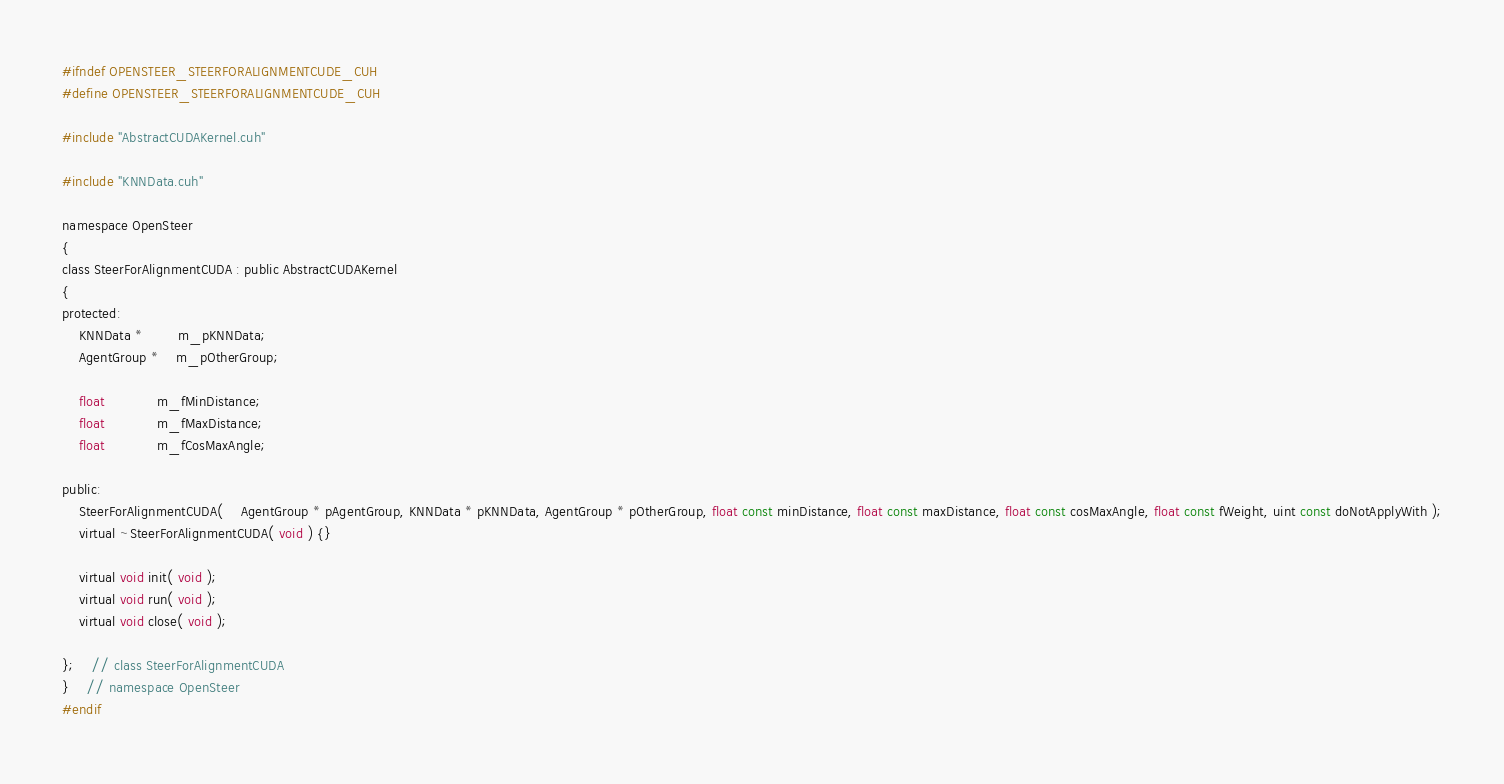<code> <loc_0><loc_0><loc_500><loc_500><_Cuda_>#ifndef OPENSTEER_STEERFORALIGNMENTCUDE_CUH
#define OPENSTEER_STEERFORALIGNMENTCUDE_CUH

#include "AbstractCUDAKernel.cuh"

#include "KNNData.cuh"

namespace OpenSteer
{
class SteerForAlignmentCUDA : public AbstractCUDAKernel
{
protected:
	KNNData *		m_pKNNData;
	AgentGroup *	m_pOtherGroup;

	float			m_fMinDistance;
	float			m_fMaxDistance;
	float			m_fCosMaxAngle;

public:
	SteerForAlignmentCUDA(	AgentGroup * pAgentGroup, KNNData * pKNNData, AgentGroup * pOtherGroup, float const minDistance, float const maxDistance, float const cosMaxAngle, float const fWeight, uint const doNotApplyWith );
	virtual ~SteerForAlignmentCUDA( void ) {}

	virtual void init( void );
	virtual void run( void );
	virtual void close( void );

};	// class SteerForAlignmentCUDA
}	// namespace OpenSteer
#endif
</code> 